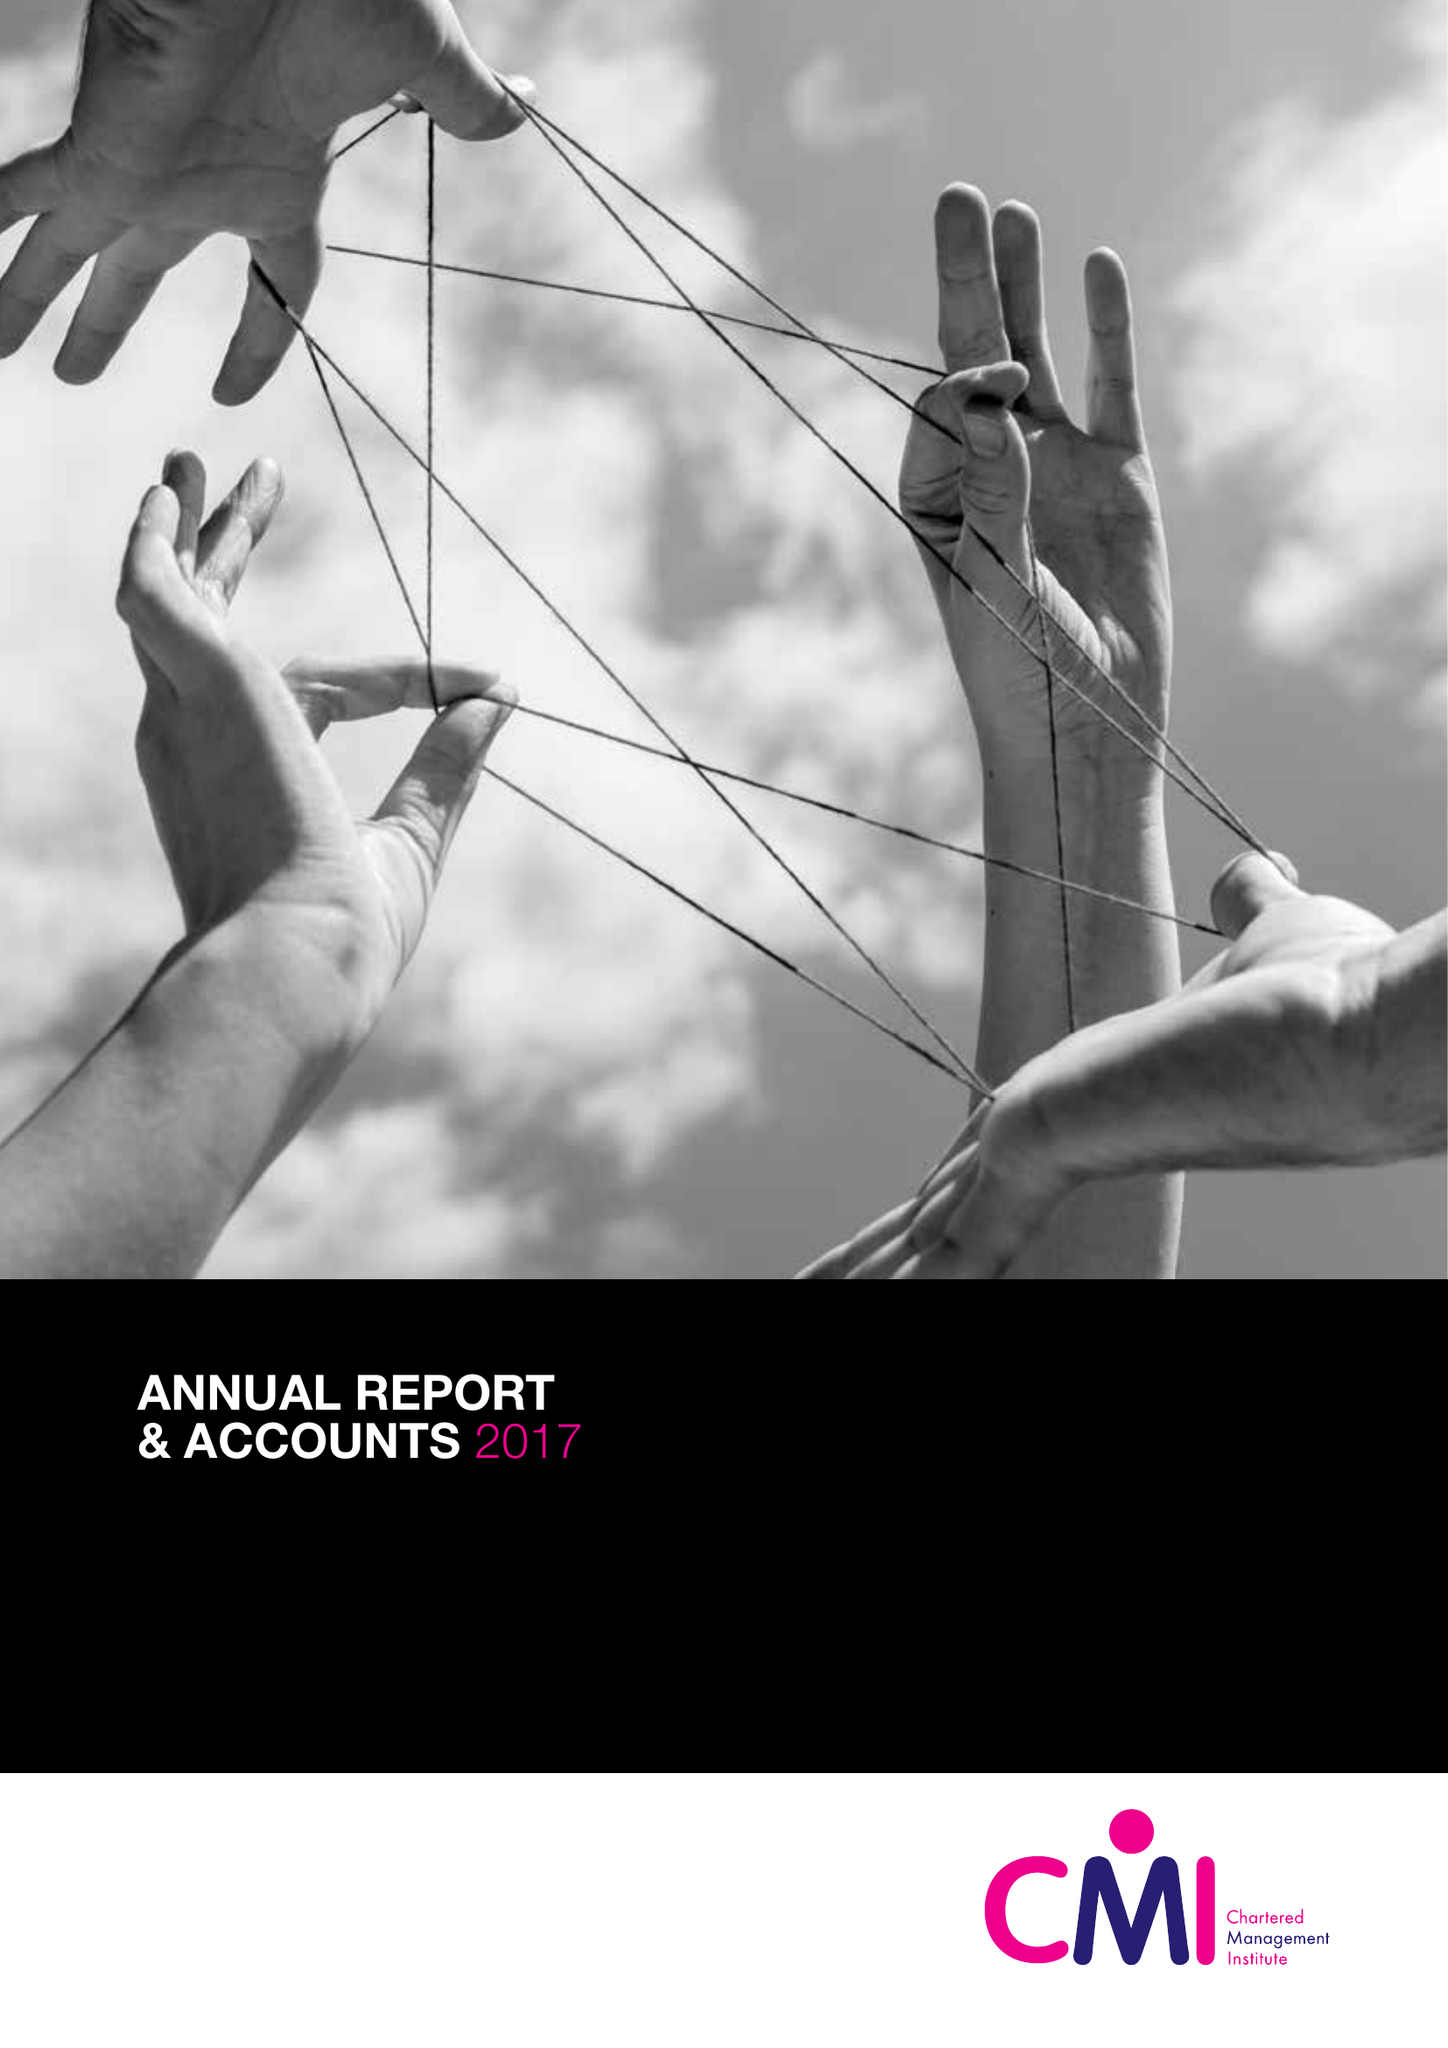What is the value for the report_date?
Answer the question using a single word or phrase. 2017-03-31 